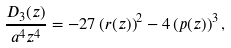Convert formula to latex. <formula><loc_0><loc_0><loc_500><loc_500>\frac { D _ { 3 } ( z ) } { a ^ { 4 } z ^ { 4 } } = - 2 7 \left ( r ( z ) \right ) ^ { 2 } - 4 \left ( p ( z ) \right ) ^ { 3 } ,</formula> 